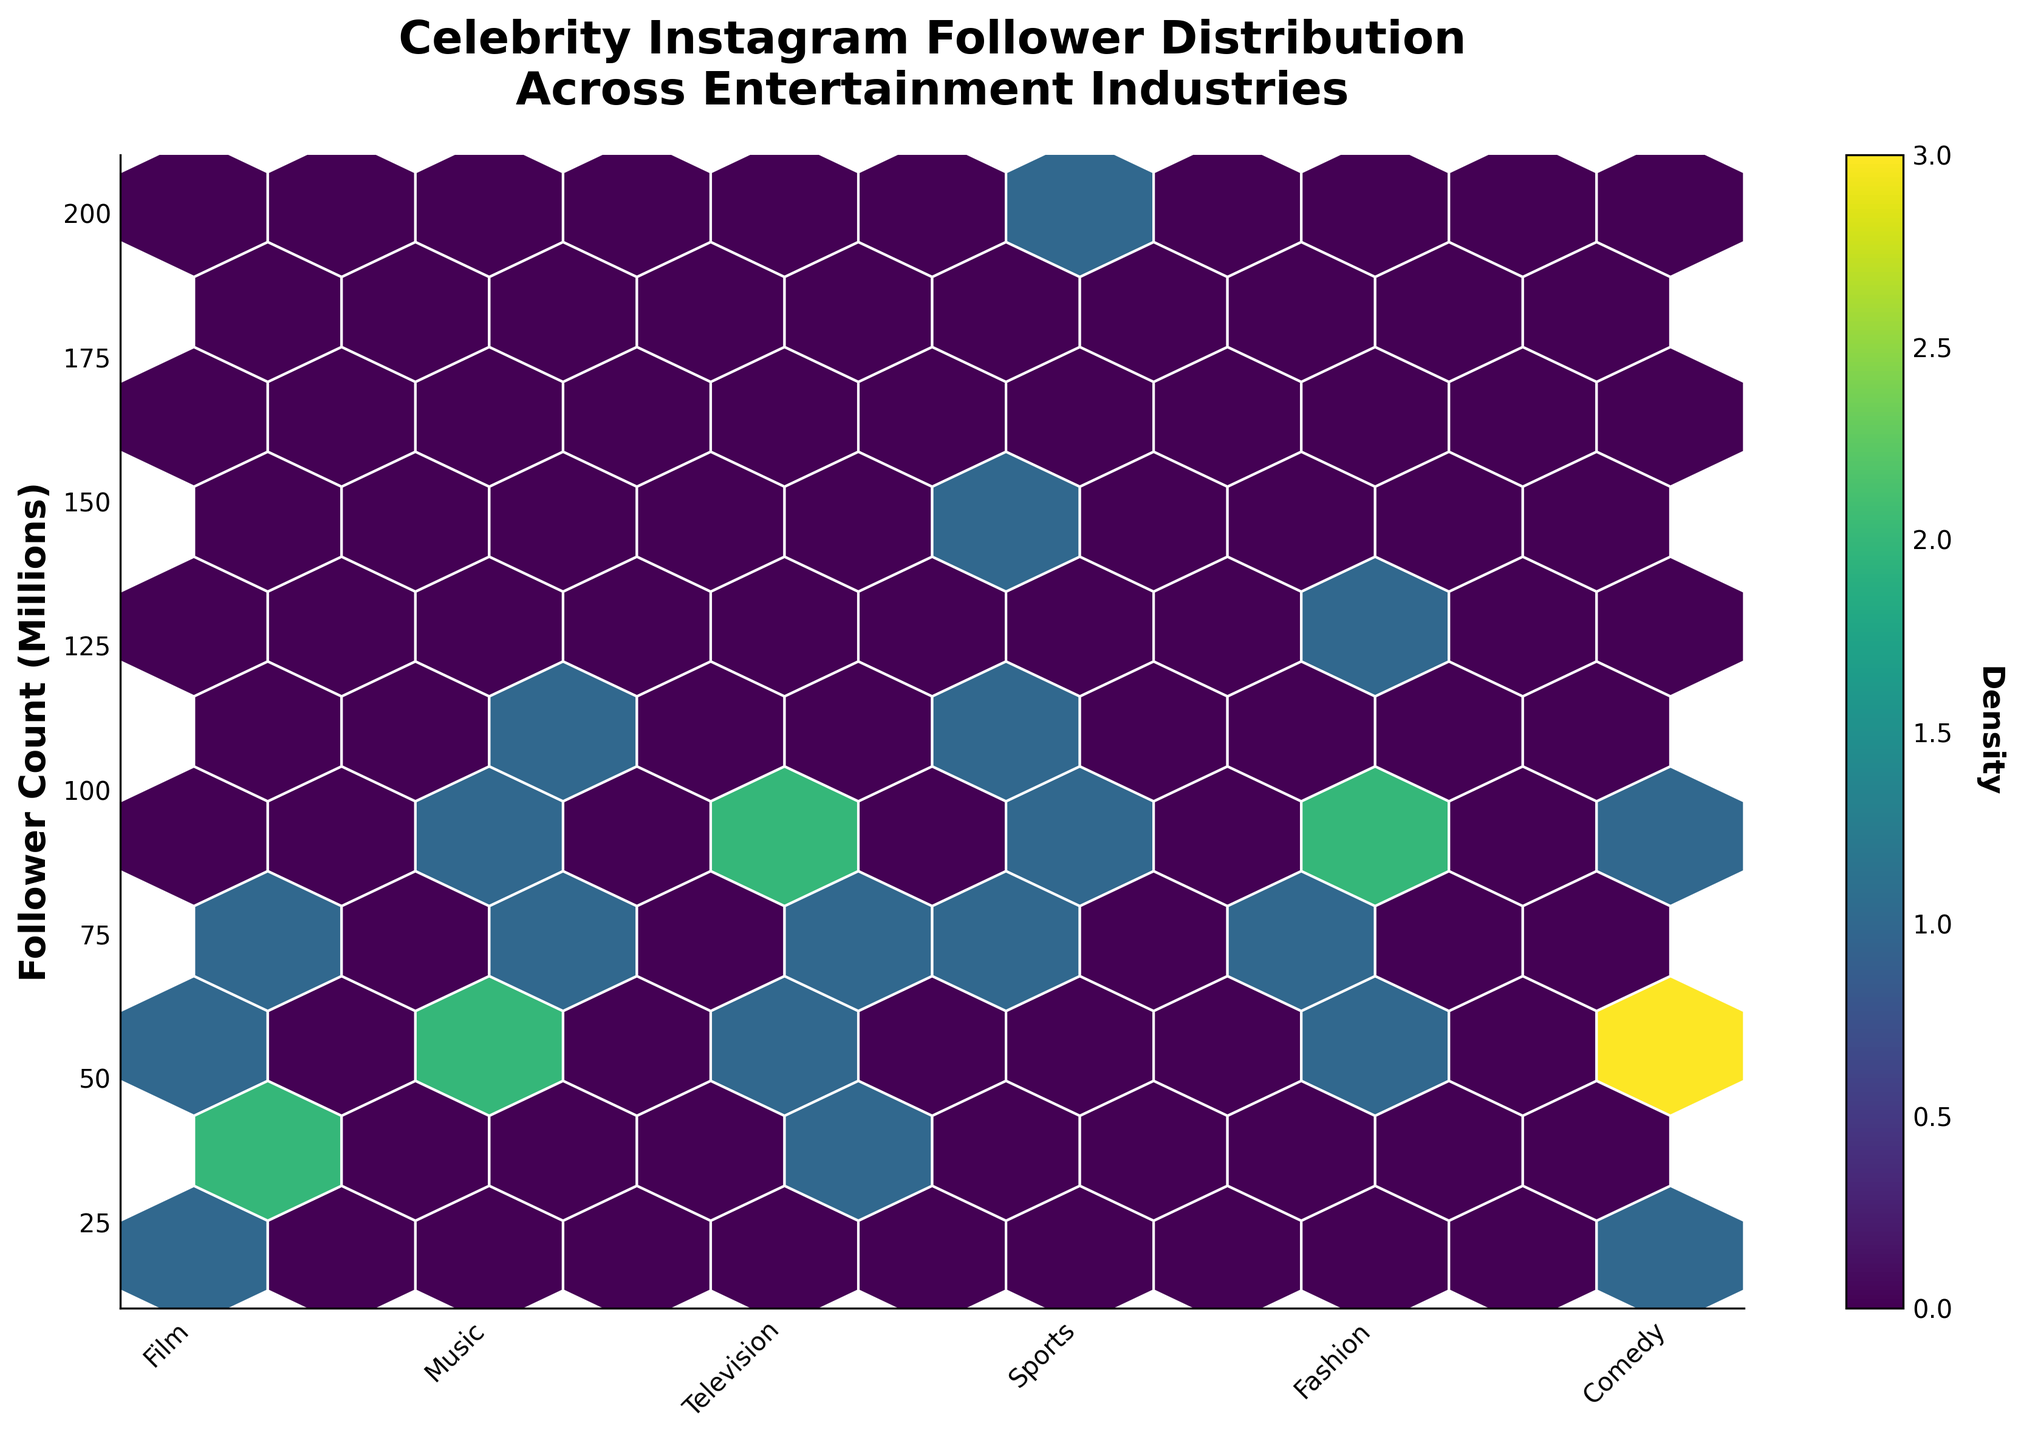What is the main title of the plot? The main title is displayed at the top of the plot and it reads "Celebrity Instagram Follower Distribution Across Entertainment Industries".
Answer: Celebrity Instagram Follower Distribution Across Entertainment Industries What is the label for the y-axis? The label for the y-axis is found along the vertical axis and it reads "Follower Count (Millions)".
Answer: Follower Count (Millions) How many distinct entertainment industries are represented in the plot? There are six categories on the x-axis, each representing a different entertainment industry.
Answer: 6 Which industry seems to have the highest density of Instagram followers? By observing the hexagonal bins, the industry with the darkest colored hexagons, indicating the highest density, appears to be "Music".
Answer: Music What is the approximate range of follower counts for the "Sports" industry? Look at the distribution of hexagons along the y-axis for the "Sports" x-axis category. They range from around 40 million to 130 million.
Answer: 40 million to 130 million Are there any industries that exhibit a follower count below 20 million? Check the distribution of hexagons, and you will see that none of the industries have follower counts below 20 million.
Answer: No Which two industries appear to have the most similar distribution of follower counts? Compare the spread and density of hexagons between pairs of industries; "Fashion" and "Film" show a similar range and density.
Answer: Fashion and Film How does the follower count distribution for "Comedy" compare to "Television"? Observe the hexagon densities and ranges for both; "Television" generally has a higher follower count and denser hexagons compared to "Comedy".
Answer: Television has higher density and range What is the follower count range for "Fashion" and how does it compare to "Music"? Identify hexagon ranges; "Fashion" ranges from about 50 million to 110 million, while "Music" ranges from around 80 million to 200 million.
Answer: Music has a larger range Is there an indication of the overall density of follower counts in the plot? The color bar helps depict this, where denser regions correlate with more followers present within particular ranges for each industry.
Answer: The denser regions are indicated by darker colors on the color bar 